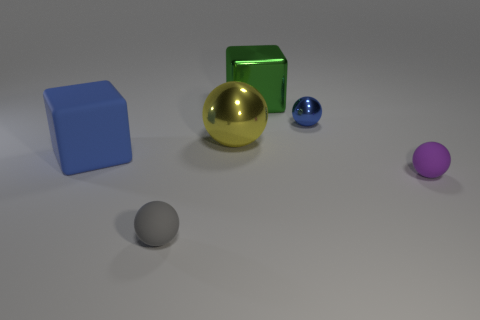Subtract all green spheres. Subtract all red cubes. How many spheres are left? 4 Add 1 blue objects. How many objects exist? 7 Subtract all spheres. How many objects are left? 2 Subtract all large yellow balls. Subtract all green blocks. How many objects are left? 4 Add 1 big spheres. How many big spheres are left? 2 Add 1 rubber spheres. How many rubber spheres exist? 3 Subtract 0 green spheres. How many objects are left? 6 